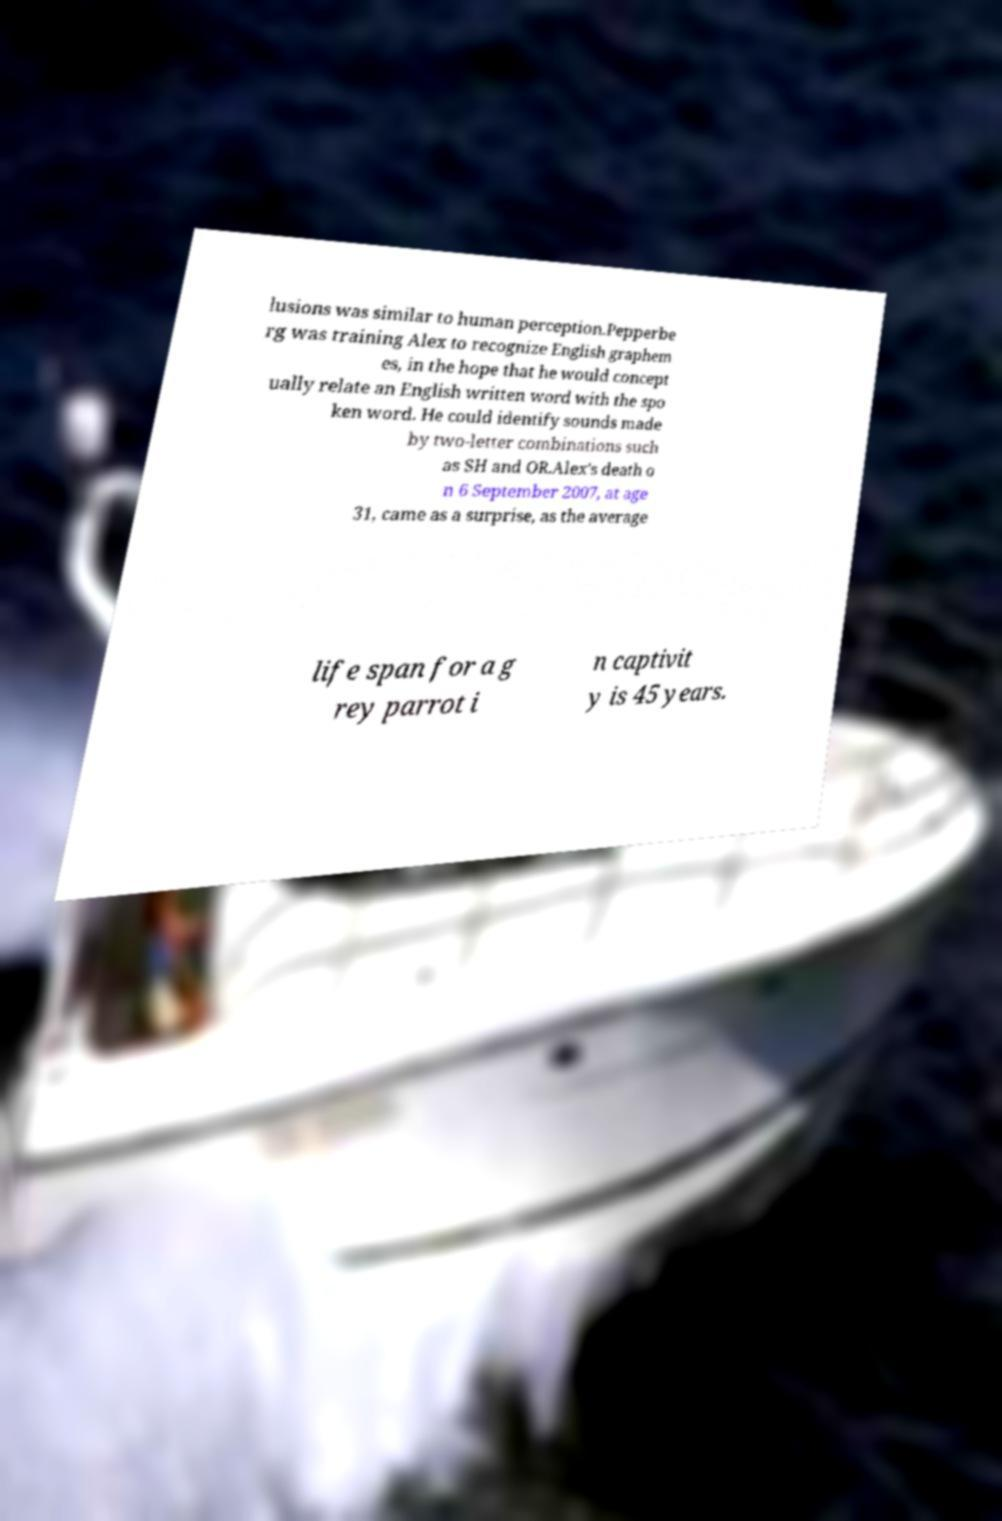I need the written content from this picture converted into text. Can you do that? lusions was similar to human perception.Pepperbe rg was training Alex to recognize English graphem es, in the hope that he would concept ually relate an English written word with the spo ken word. He could identify sounds made by two-letter combinations such as SH and OR.Alex's death o n 6 September 2007, at age 31, came as a surprise, as the average life span for a g rey parrot i n captivit y is 45 years. 